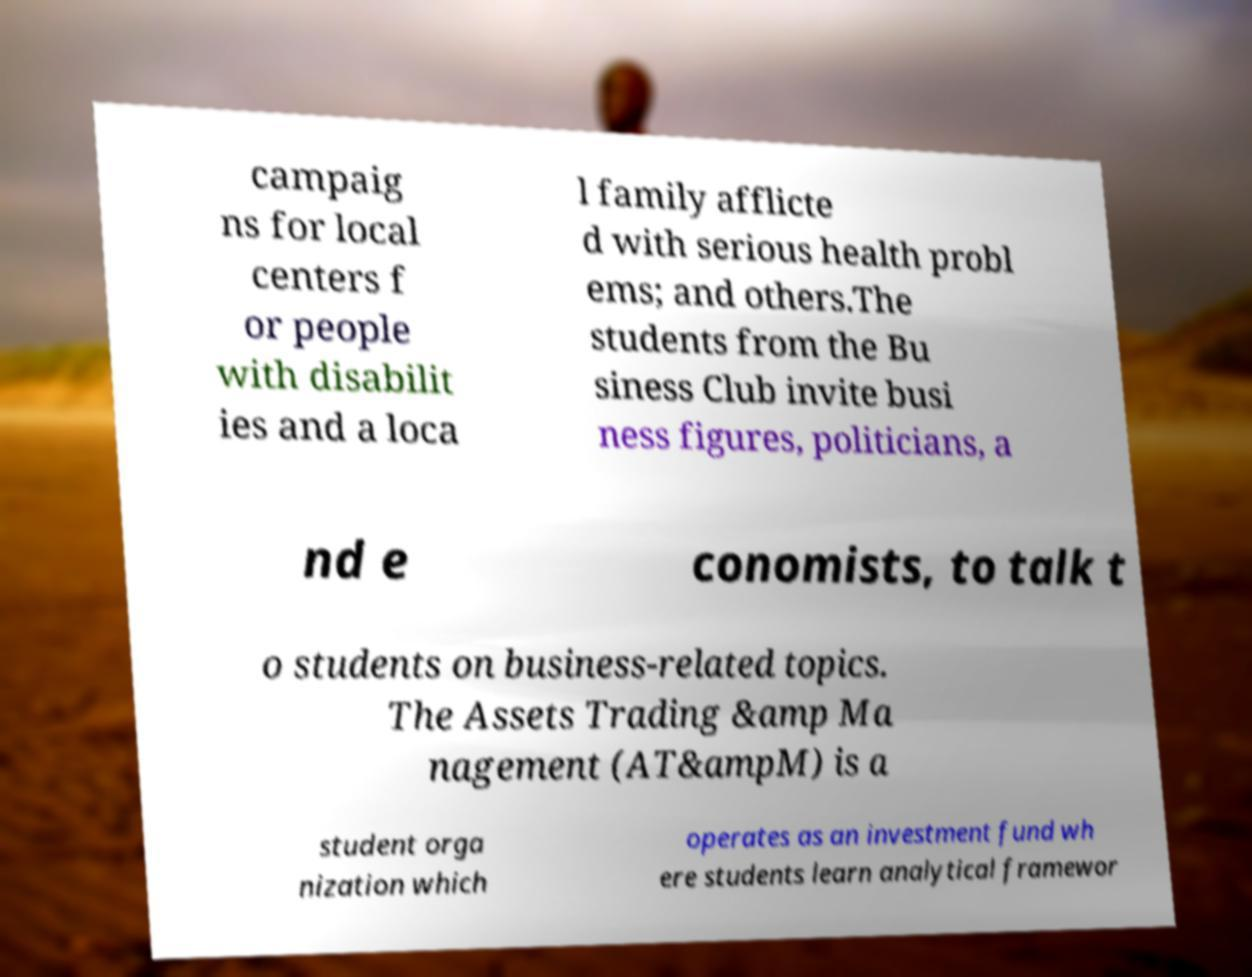Can you read and provide the text displayed in the image?This photo seems to have some interesting text. Can you extract and type it out for me? campaig ns for local centers f or people with disabilit ies and a loca l family afflicte d with serious health probl ems; and others.The students from the Bu siness Club invite busi ness figures, politicians, a nd e conomists, to talk t o students on business-related topics. The Assets Trading &amp Ma nagement (AT&ampM) is a student orga nization which operates as an investment fund wh ere students learn analytical framewor 